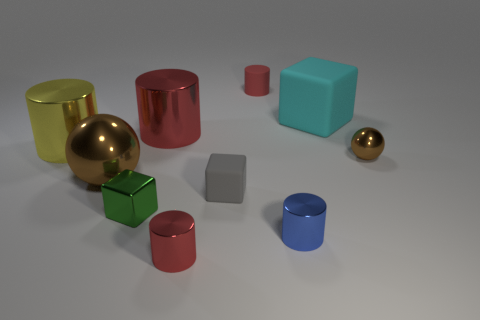What number of shiny objects are either large spheres or blue blocks?
Offer a terse response. 1. Is there a matte cube that has the same size as the blue metal cylinder?
Offer a very short reply. Yes. Are there more cyan rubber objects that are behind the big brown thing than big red matte things?
Your answer should be very brief. Yes. How many big objects are either red cylinders or yellow cylinders?
Offer a terse response. 2. What number of other gray rubber objects are the same shape as the small gray object?
Give a very brief answer. 0. What is the material of the tiny red cylinder to the left of the small red thing that is behind the green block?
Your response must be concise. Metal. There is a yellow shiny cylinder that is on the left side of the big matte thing; what is its size?
Offer a terse response. Large. What number of cyan objects are either small things or large metallic cylinders?
Give a very brief answer. 0. Is there anything else that has the same material as the large brown sphere?
Your answer should be compact. Yes. There is a big red thing that is the same shape as the blue metallic object; what is its material?
Your response must be concise. Metal. 